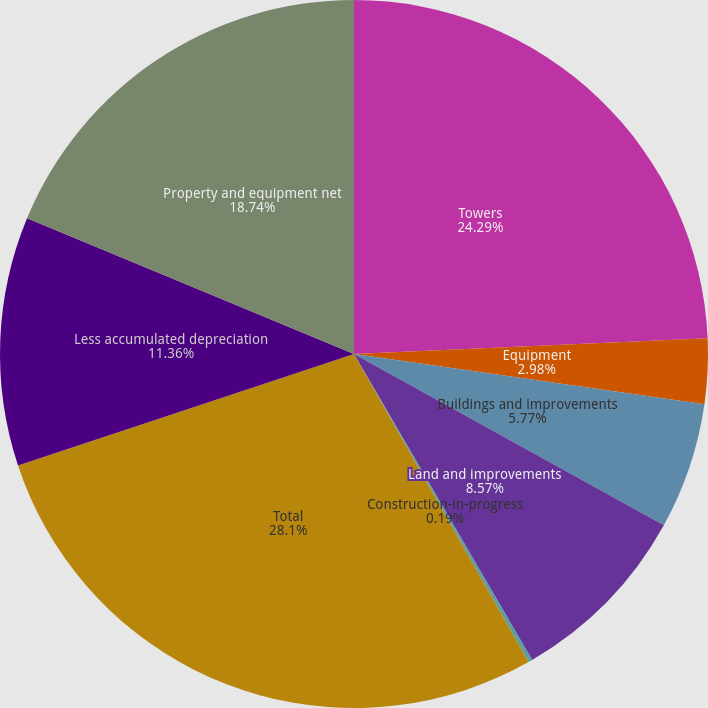Convert chart to OTSL. <chart><loc_0><loc_0><loc_500><loc_500><pie_chart><fcel>Towers<fcel>Equipment<fcel>Buildings and improvements<fcel>Land and improvements<fcel>Construction-in-progress<fcel>Total<fcel>Less accumulated depreciation<fcel>Property and equipment net<nl><fcel>24.29%<fcel>2.98%<fcel>5.77%<fcel>8.57%<fcel>0.19%<fcel>28.11%<fcel>11.36%<fcel>18.74%<nl></chart> 